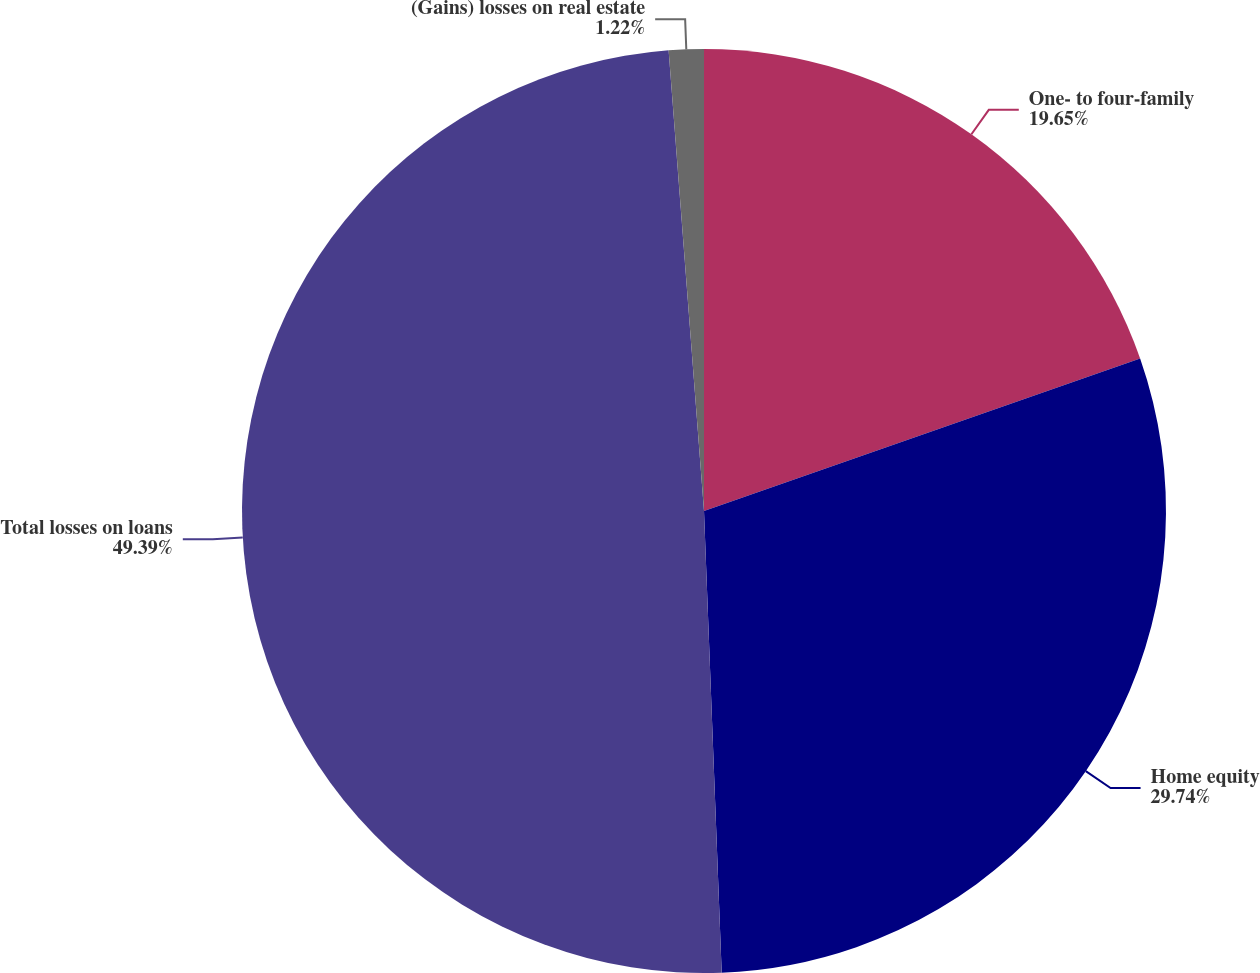<chart> <loc_0><loc_0><loc_500><loc_500><pie_chart><fcel>One- to four-family<fcel>Home equity<fcel>Total losses on loans<fcel>(Gains) losses on real estate<nl><fcel>19.65%<fcel>29.74%<fcel>49.39%<fcel>1.22%<nl></chart> 